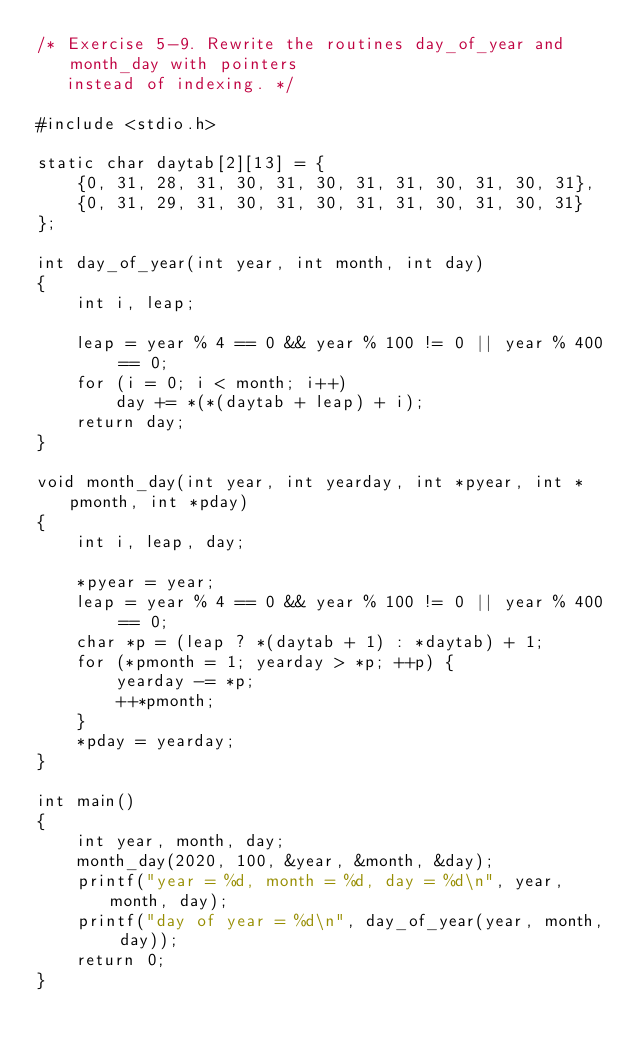Convert code to text. <code><loc_0><loc_0><loc_500><loc_500><_C_>/* Exercise 5-9. Rewrite the routines day_of_year and month_day with pointers
   instead of indexing. */

#include <stdio.h>

static char daytab[2][13] = {
    {0, 31, 28, 31, 30, 31, 30, 31, 31, 30, 31, 30, 31},
    {0, 31, 29, 31, 30, 31, 30, 31, 31, 30, 31, 30, 31}
};

int day_of_year(int year, int month, int day)
{
    int i, leap;

    leap = year % 4 == 0 && year % 100 != 0 || year % 400 == 0;
    for (i = 0; i < month; i++)
        day += *(*(daytab + leap) + i);
    return day;
}

void month_day(int year, int yearday, int *pyear, int *pmonth, int *pday)
{
    int i, leap, day;

    *pyear = year;
    leap = year % 4 == 0 && year % 100 != 0 || year % 400 == 0;
    char *p = (leap ? *(daytab + 1) : *daytab) + 1;
    for (*pmonth = 1; yearday > *p; ++p) {
        yearday -= *p;
        ++*pmonth;
    }
    *pday = yearday;
}

int main()
{
    int year, month, day;
    month_day(2020, 100, &year, &month, &day);
    printf("year = %d, month = %d, day = %d\n", year, month, day);
    printf("day of year = %d\n", day_of_year(year, month, day));
    return 0;
}
</code> 